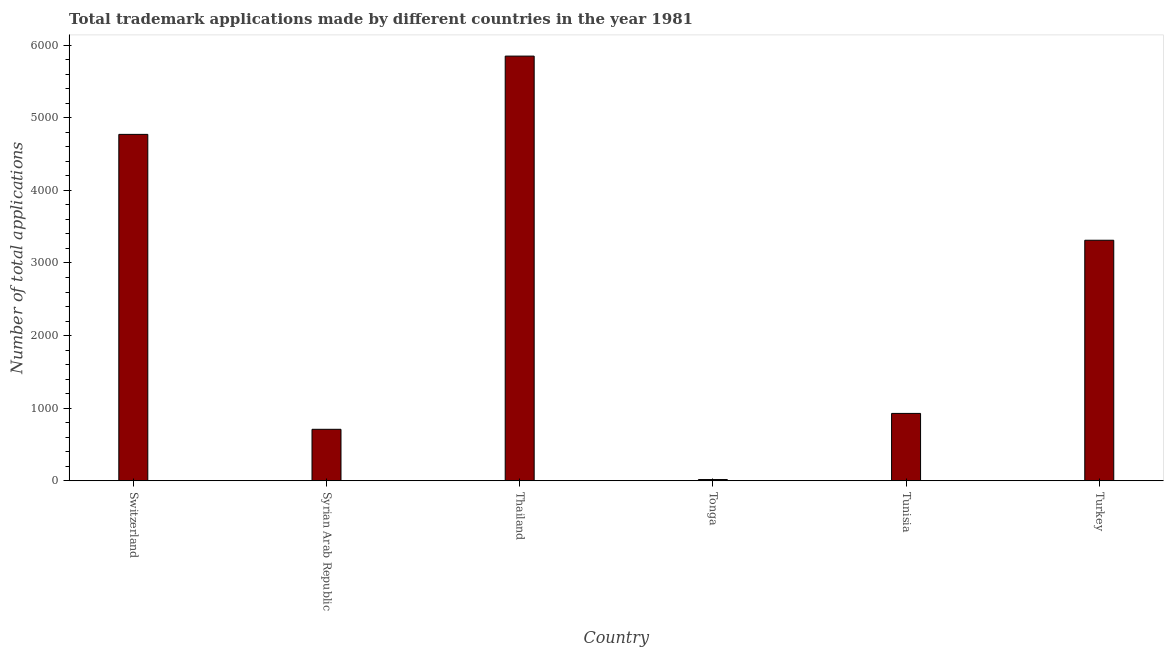Does the graph contain any zero values?
Your answer should be very brief. No. What is the title of the graph?
Provide a succinct answer. Total trademark applications made by different countries in the year 1981. What is the label or title of the X-axis?
Offer a very short reply. Country. What is the label or title of the Y-axis?
Your answer should be very brief. Number of total applications. What is the number of trademark applications in Thailand?
Your response must be concise. 5849. Across all countries, what is the maximum number of trademark applications?
Offer a terse response. 5849. Across all countries, what is the minimum number of trademark applications?
Keep it short and to the point. 17. In which country was the number of trademark applications maximum?
Your response must be concise. Thailand. In which country was the number of trademark applications minimum?
Give a very brief answer. Tonga. What is the sum of the number of trademark applications?
Offer a terse response. 1.56e+04. What is the difference between the number of trademark applications in Thailand and Tunisia?
Your response must be concise. 4921. What is the average number of trademark applications per country?
Your answer should be very brief. 2597. What is the median number of trademark applications?
Offer a terse response. 2120.5. What is the ratio of the number of trademark applications in Switzerland to that in Syrian Arab Republic?
Your answer should be very brief. 6.73. Is the difference between the number of trademark applications in Switzerland and Thailand greater than the difference between any two countries?
Your response must be concise. No. What is the difference between the highest and the second highest number of trademark applications?
Keep it short and to the point. 1078. What is the difference between the highest and the lowest number of trademark applications?
Make the answer very short. 5832. How many bars are there?
Provide a succinct answer. 6. Are all the bars in the graph horizontal?
Offer a terse response. No. How many countries are there in the graph?
Offer a very short reply. 6. Are the values on the major ticks of Y-axis written in scientific E-notation?
Offer a very short reply. No. What is the Number of total applications in Switzerland?
Ensure brevity in your answer.  4771. What is the Number of total applications of Syrian Arab Republic?
Offer a terse response. 709. What is the Number of total applications of Thailand?
Keep it short and to the point. 5849. What is the Number of total applications of Tonga?
Your answer should be compact. 17. What is the Number of total applications in Tunisia?
Keep it short and to the point. 928. What is the Number of total applications of Turkey?
Your answer should be compact. 3313. What is the difference between the Number of total applications in Switzerland and Syrian Arab Republic?
Provide a short and direct response. 4062. What is the difference between the Number of total applications in Switzerland and Thailand?
Ensure brevity in your answer.  -1078. What is the difference between the Number of total applications in Switzerland and Tonga?
Your response must be concise. 4754. What is the difference between the Number of total applications in Switzerland and Tunisia?
Offer a very short reply. 3843. What is the difference between the Number of total applications in Switzerland and Turkey?
Offer a terse response. 1458. What is the difference between the Number of total applications in Syrian Arab Republic and Thailand?
Provide a short and direct response. -5140. What is the difference between the Number of total applications in Syrian Arab Republic and Tonga?
Your answer should be compact. 692. What is the difference between the Number of total applications in Syrian Arab Republic and Tunisia?
Keep it short and to the point. -219. What is the difference between the Number of total applications in Syrian Arab Republic and Turkey?
Your response must be concise. -2604. What is the difference between the Number of total applications in Thailand and Tonga?
Provide a succinct answer. 5832. What is the difference between the Number of total applications in Thailand and Tunisia?
Give a very brief answer. 4921. What is the difference between the Number of total applications in Thailand and Turkey?
Give a very brief answer. 2536. What is the difference between the Number of total applications in Tonga and Tunisia?
Your response must be concise. -911. What is the difference between the Number of total applications in Tonga and Turkey?
Keep it short and to the point. -3296. What is the difference between the Number of total applications in Tunisia and Turkey?
Offer a terse response. -2385. What is the ratio of the Number of total applications in Switzerland to that in Syrian Arab Republic?
Give a very brief answer. 6.73. What is the ratio of the Number of total applications in Switzerland to that in Thailand?
Keep it short and to the point. 0.82. What is the ratio of the Number of total applications in Switzerland to that in Tonga?
Your response must be concise. 280.65. What is the ratio of the Number of total applications in Switzerland to that in Tunisia?
Offer a terse response. 5.14. What is the ratio of the Number of total applications in Switzerland to that in Turkey?
Give a very brief answer. 1.44. What is the ratio of the Number of total applications in Syrian Arab Republic to that in Thailand?
Keep it short and to the point. 0.12. What is the ratio of the Number of total applications in Syrian Arab Republic to that in Tonga?
Your answer should be very brief. 41.71. What is the ratio of the Number of total applications in Syrian Arab Republic to that in Tunisia?
Make the answer very short. 0.76. What is the ratio of the Number of total applications in Syrian Arab Republic to that in Turkey?
Your answer should be very brief. 0.21. What is the ratio of the Number of total applications in Thailand to that in Tonga?
Your response must be concise. 344.06. What is the ratio of the Number of total applications in Thailand to that in Tunisia?
Offer a terse response. 6.3. What is the ratio of the Number of total applications in Thailand to that in Turkey?
Ensure brevity in your answer.  1.76. What is the ratio of the Number of total applications in Tonga to that in Tunisia?
Ensure brevity in your answer.  0.02. What is the ratio of the Number of total applications in Tonga to that in Turkey?
Give a very brief answer. 0.01. What is the ratio of the Number of total applications in Tunisia to that in Turkey?
Keep it short and to the point. 0.28. 